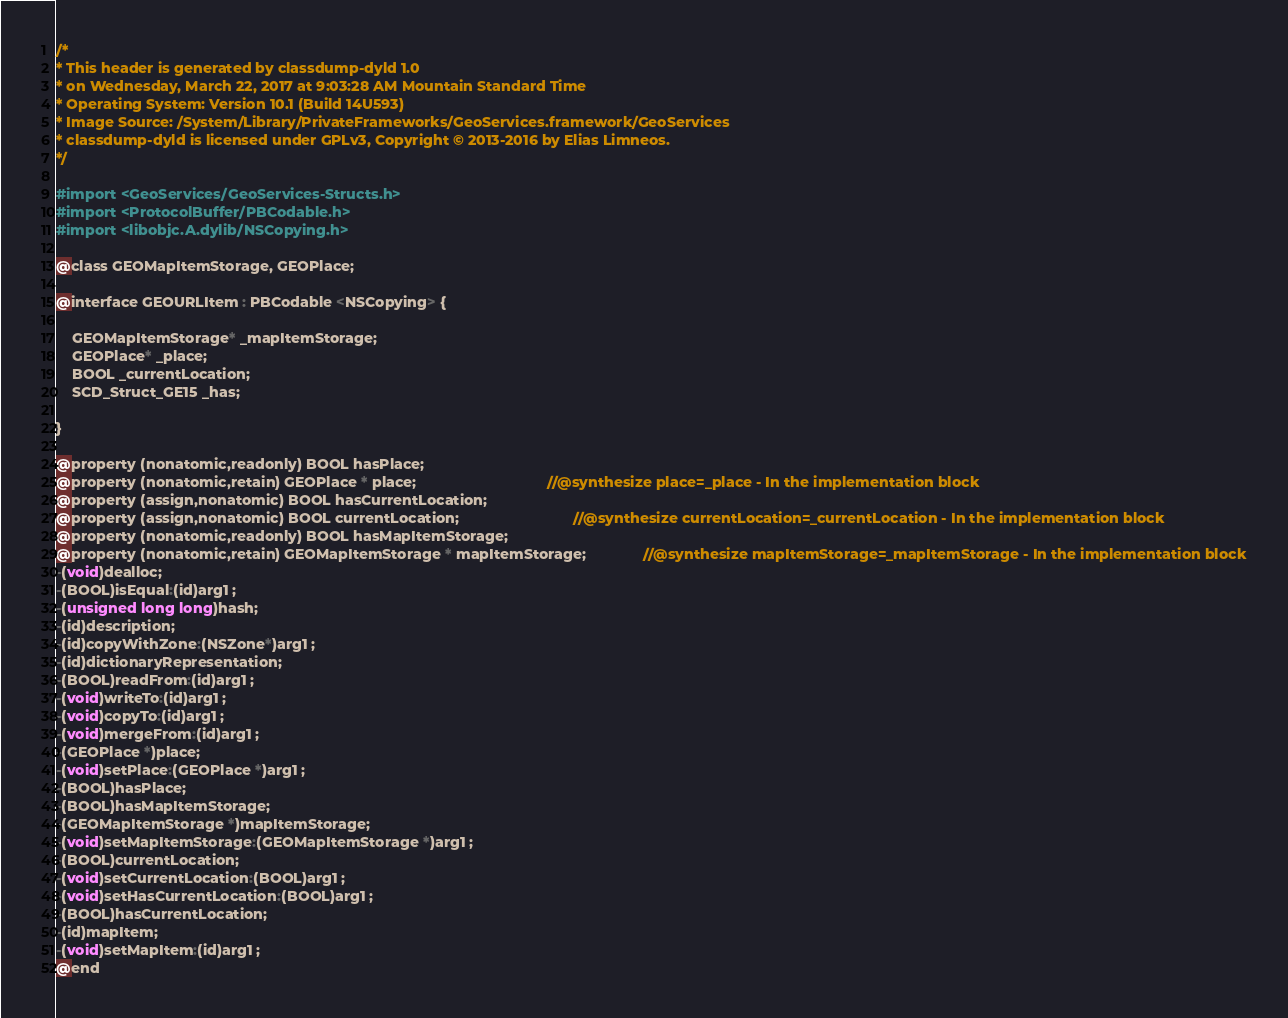<code> <loc_0><loc_0><loc_500><loc_500><_C_>/*
* This header is generated by classdump-dyld 1.0
* on Wednesday, March 22, 2017 at 9:03:28 AM Mountain Standard Time
* Operating System: Version 10.1 (Build 14U593)
* Image Source: /System/Library/PrivateFrameworks/GeoServices.framework/GeoServices
* classdump-dyld is licensed under GPLv3, Copyright © 2013-2016 by Elias Limneos.
*/

#import <GeoServices/GeoServices-Structs.h>
#import <ProtocolBuffer/PBCodable.h>
#import <libobjc.A.dylib/NSCopying.h>

@class GEOMapItemStorage, GEOPlace;

@interface GEOURLItem : PBCodable <NSCopying> {

	GEOMapItemStorage* _mapItemStorage;
	GEOPlace* _place;
	BOOL _currentLocation;
	SCD_Struct_GE15 _has;

}

@property (nonatomic,readonly) BOOL hasPlace; 
@property (nonatomic,retain) GEOPlace * place;                                //@synthesize place=_place - In the implementation block
@property (assign,nonatomic) BOOL hasCurrentLocation; 
@property (assign,nonatomic) BOOL currentLocation;                            //@synthesize currentLocation=_currentLocation - In the implementation block
@property (nonatomic,readonly) BOOL hasMapItemStorage; 
@property (nonatomic,retain) GEOMapItemStorage * mapItemStorage;              //@synthesize mapItemStorage=_mapItemStorage - In the implementation block
-(void)dealloc;
-(BOOL)isEqual:(id)arg1 ;
-(unsigned long long)hash;
-(id)description;
-(id)copyWithZone:(NSZone*)arg1 ;
-(id)dictionaryRepresentation;
-(BOOL)readFrom:(id)arg1 ;
-(void)writeTo:(id)arg1 ;
-(void)copyTo:(id)arg1 ;
-(void)mergeFrom:(id)arg1 ;
-(GEOPlace *)place;
-(void)setPlace:(GEOPlace *)arg1 ;
-(BOOL)hasPlace;
-(BOOL)hasMapItemStorage;
-(GEOMapItemStorage *)mapItemStorage;
-(void)setMapItemStorage:(GEOMapItemStorage *)arg1 ;
-(BOOL)currentLocation;
-(void)setCurrentLocation:(BOOL)arg1 ;
-(void)setHasCurrentLocation:(BOOL)arg1 ;
-(BOOL)hasCurrentLocation;
-(id)mapItem;
-(void)setMapItem:(id)arg1 ;
@end

</code> 